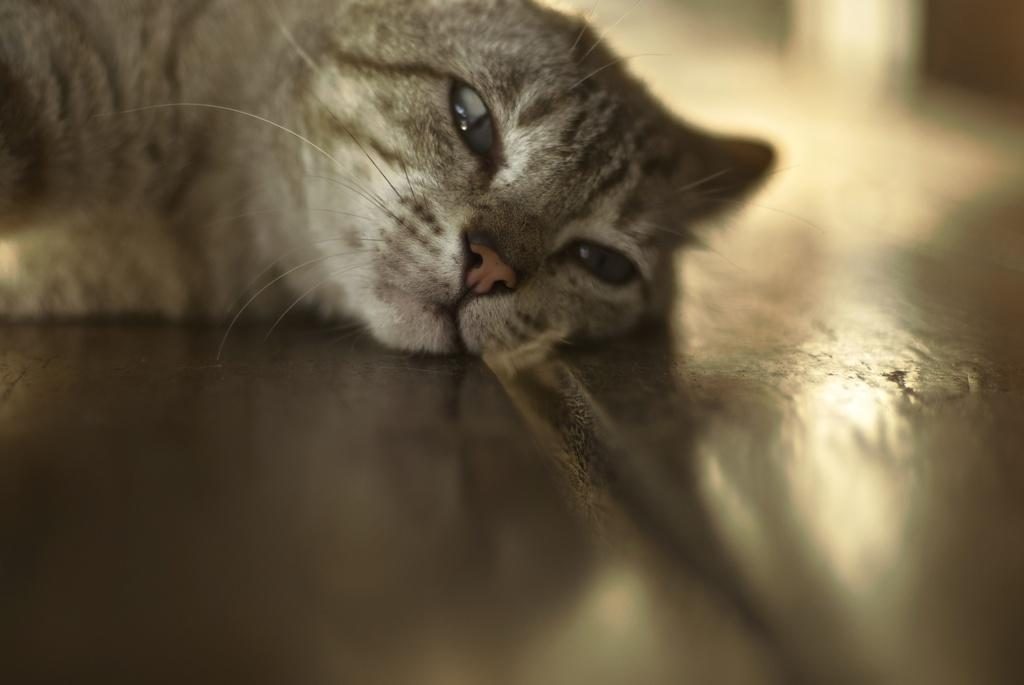What type of animal is present in the image? There is a cat in the image. What is the cat doing in the image? The cat is lying on the floor. What team does the cat support in the image? There is no indication of a team or any sports-related activity in the image, as it simply features a cat lying on the floor. 